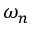Convert formula to latex. <formula><loc_0><loc_0><loc_500><loc_500>\omega _ { n }</formula> 